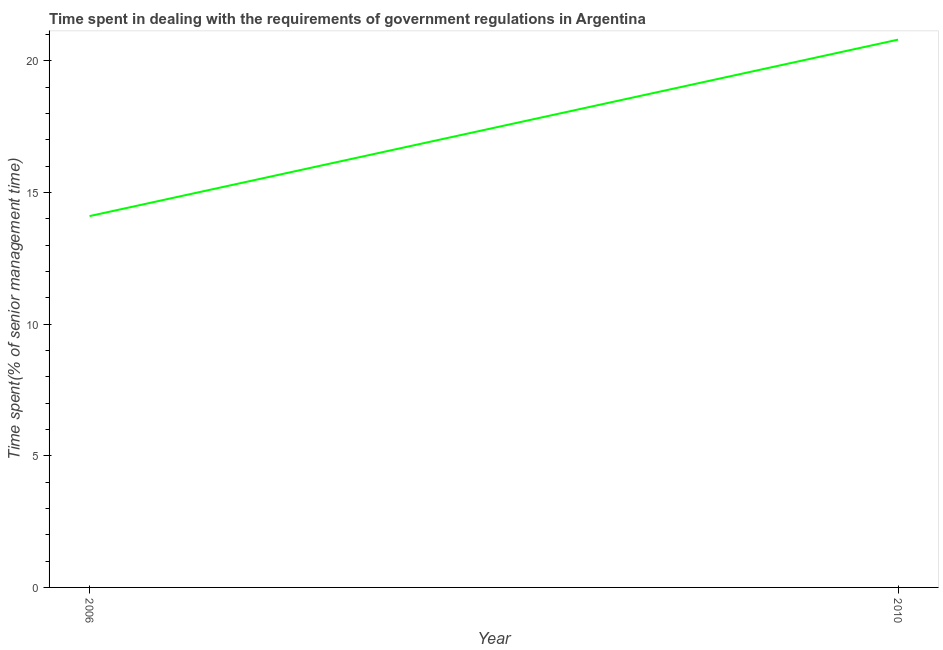Across all years, what is the maximum time spent in dealing with government regulations?
Make the answer very short. 20.8. What is the sum of the time spent in dealing with government regulations?
Give a very brief answer. 34.9. What is the difference between the time spent in dealing with government regulations in 2006 and 2010?
Offer a terse response. -6.7. What is the average time spent in dealing with government regulations per year?
Your answer should be compact. 17.45. What is the median time spent in dealing with government regulations?
Your response must be concise. 17.45. In how many years, is the time spent in dealing with government regulations greater than 17 %?
Give a very brief answer. 1. Do a majority of the years between 2010 and 2006 (inclusive) have time spent in dealing with government regulations greater than 9 %?
Provide a short and direct response. No. What is the ratio of the time spent in dealing with government regulations in 2006 to that in 2010?
Offer a terse response. 0.68. Is the time spent in dealing with government regulations in 2006 less than that in 2010?
Your answer should be very brief. Yes. In how many years, is the time spent in dealing with government regulations greater than the average time spent in dealing with government regulations taken over all years?
Give a very brief answer. 1. What is the difference between two consecutive major ticks on the Y-axis?
Make the answer very short. 5. Does the graph contain any zero values?
Provide a short and direct response. No. What is the title of the graph?
Your answer should be compact. Time spent in dealing with the requirements of government regulations in Argentina. What is the label or title of the X-axis?
Offer a very short reply. Year. What is the label or title of the Y-axis?
Your answer should be very brief. Time spent(% of senior management time). What is the Time spent(% of senior management time) in 2010?
Provide a short and direct response. 20.8. What is the ratio of the Time spent(% of senior management time) in 2006 to that in 2010?
Your answer should be compact. 0.68. 